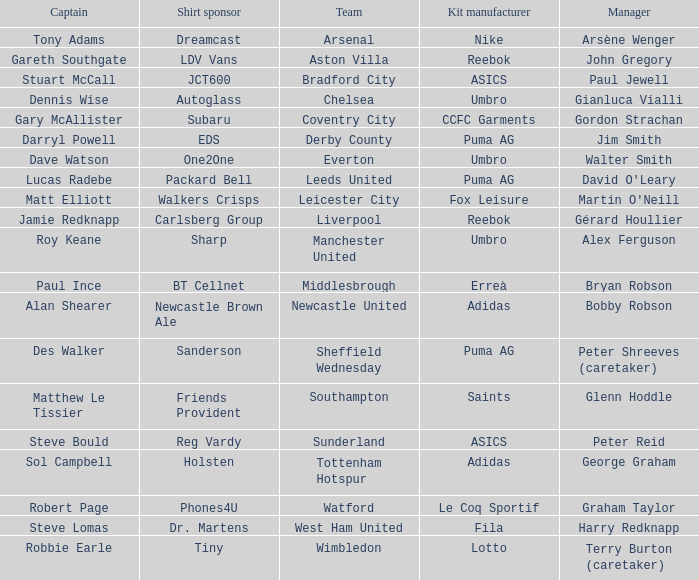Which kit producer is associated with the everton team? Umbro. 